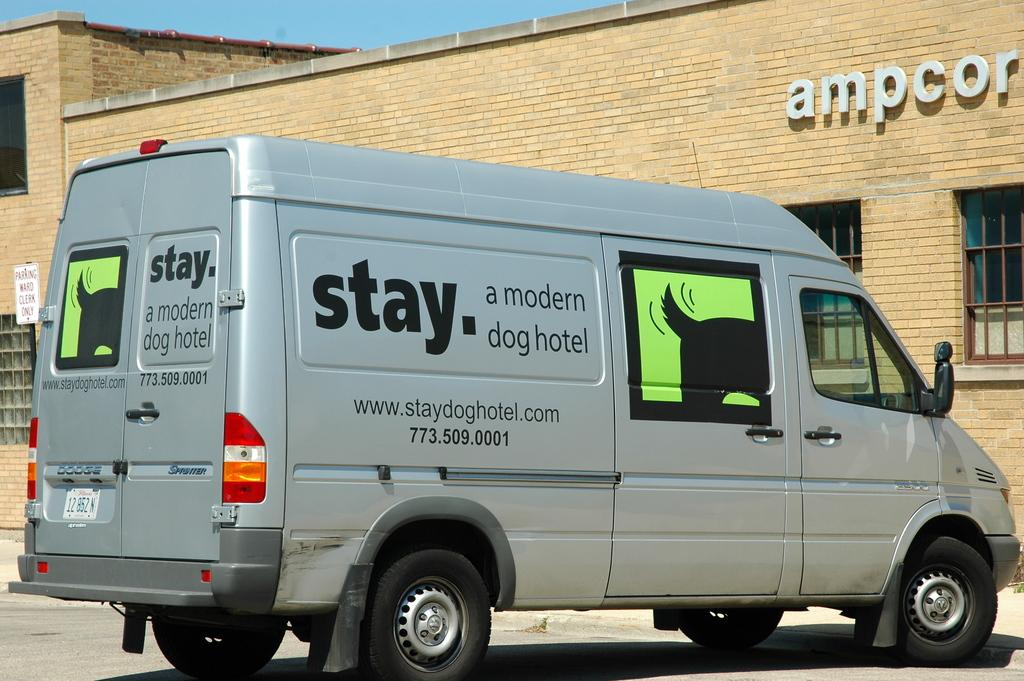<image>
Present a compact description of the photo's key features. A van decorated with a picture of a dogs wagging tail belongs to the dog hotel company. 